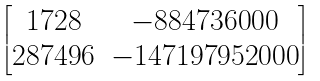<formula> <loc_0><loc_0><loc_500><loc_500>\begin{bmatrix} 1 7 2 8 & - 8 8 4 7 3 6 0 0 0 \\ 2 8 7 4 9 6 & - 1 4 7 1 9 7 9 5 2 0 0 0 \end{bmatrix}</formula> 